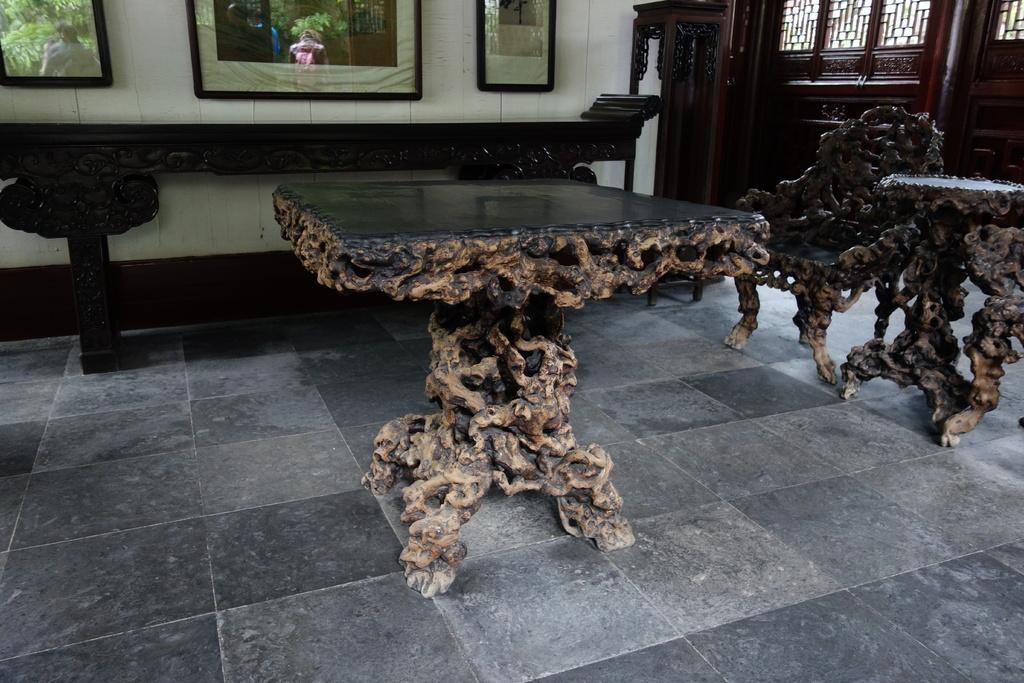What type of furniture is visible in the image? There are tables and at least one chair in the image. What can be seen hanging on the walls in the image? There are photo frames in the image. What is depicted in the photo frames? There is a reflection of people standing on the photo frames. What type of thread is being used to hold the rod in the image? There is no rod or thread present in the image. How many attempts were made to balance the object on the chair in the image? There is no object being balanced on the chair in the image. 